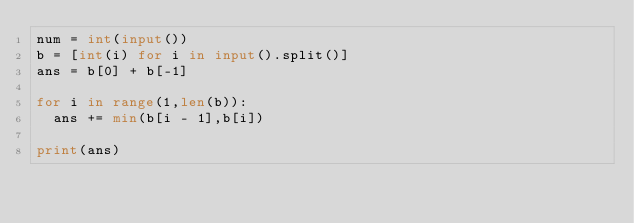Convert code to text. <code><loc_0><loc_0><loc_500><loc_500><_Python_>num = int(input())
b = [int(i) for i in input().split()]
ans = b[0] + b[-1]

for i in range(1,len(b)):
  ans += min(b[i - 1],b[i])
  
print(ans)</code> 